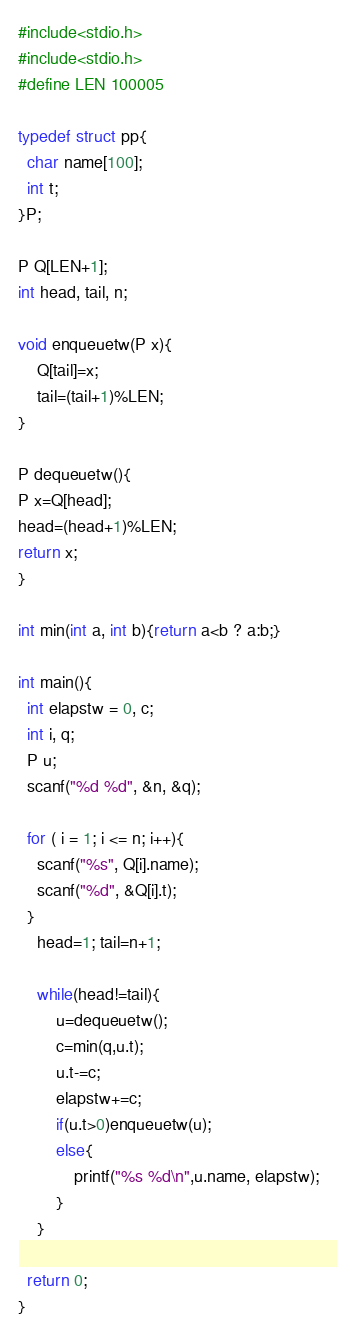Convert code to text. <code><loc_0><loc_0><loc_500><loc_500><_C_>#include<stdio.h>
#include<stdio.h>
#define LEN 100005

typedef struct pp{
  char name[100];
  int t;
}P;

P Q[LEN+1];
int head, tail, n;

void enqueuetw(P x){
    Q[tail]=x;
    tail=(tail+1)%LEN;
}

P dequeuetw(){
P x=Q[head];
head=(head+1)%LEN;
return x;
}

int min(int a, int b){return a<b ? a:b;}

int main(){
  int elapstw = 0, c;
  int i, q;
  P u;
  scanf("%d %d", &n, &q);

  for ( i = 1; i <= n; i++){
    scanf("%s", Q[i].name);
    scanf("%d", &Q[i].t);
  }
    head=1; tail=n+1;

    while(head!=tail){
        u=dequeuetw();
        c=min(q,u.t);
        u.t-=c;
        elapstw+=c;
        if(u.t>0)enqueuetw(u);
        else{
            printf("%s %d\n",u.name, elapstw);
        }
    }
  
  return 0;
}
</code> 